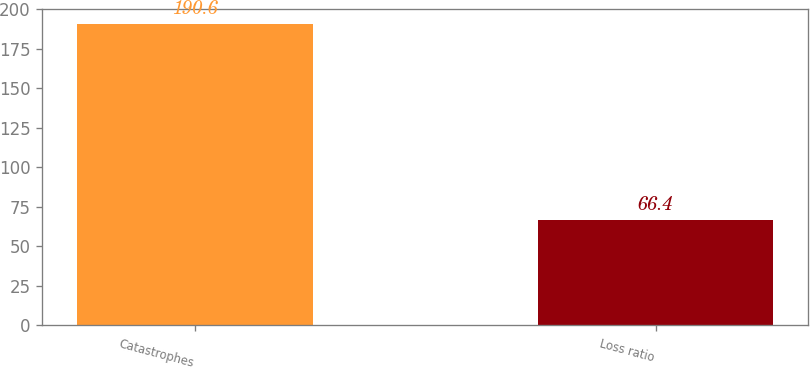<chart> <loc_0><loc_0><loc_500><loc_500><bar_chart><fcel>Catastrophes<fcel>Loss ratio<nl><fcel>190.6<fcel>66.4<nl></chart> 